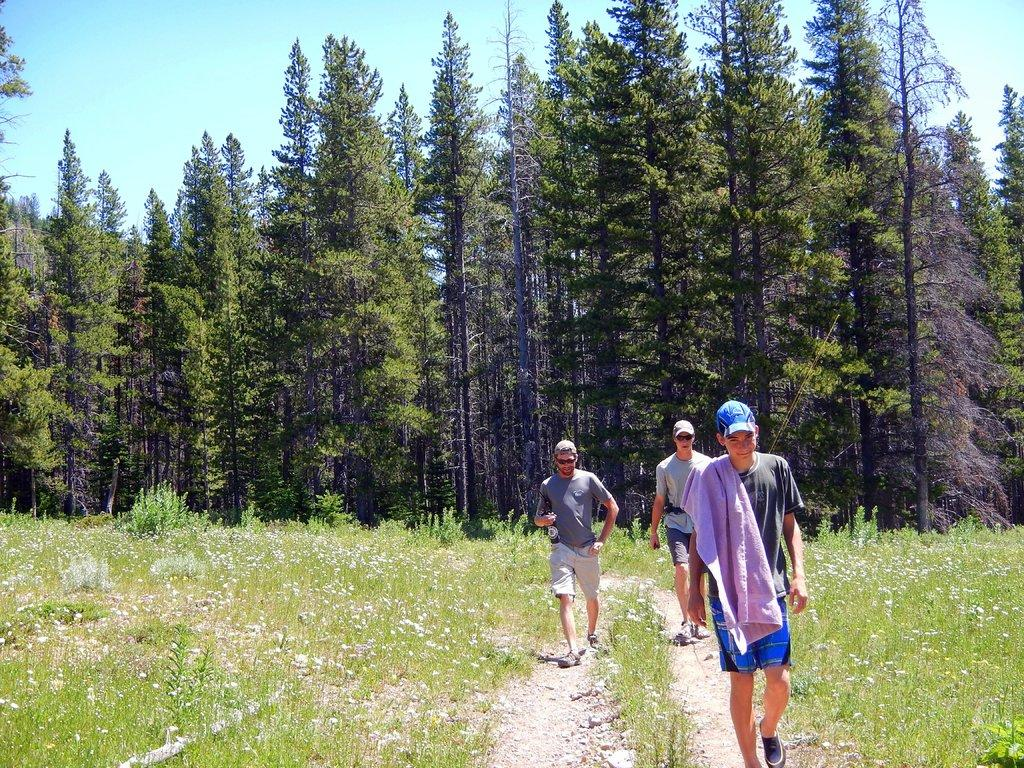How many people are in the image? There are three men in the image. What are the men doing in the image? The men are walking on a path in the image. What type of vegetation can be seen in the image? There are plants, flowers, and trees in the image. What is visible in the background of the image? The sky is visible in the background of the image. What type of furniture can be seen in the image? There is no furniture present in the image; it features three men walking on a path surrounded by plants, flowers, and trees. What flavor of mint is being grown in the image? There is no mint plant visible in the image, and therefore no specific flavor can be determined. 